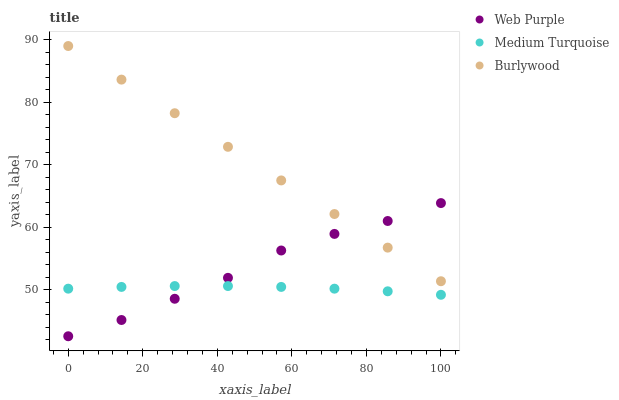Does Medium Turquoise have the minimum area under the curve?
Answer yes or no. Yes. Does Burlywood have the maximum area under the curve?
Answer yes or no. Yes. Does Web Purple have the minimum area under the curve?
Answer yes or no. No. Does Web Purple have the maximum area under the curve?
Answer yes or no. No. Is Burlywood the smoothest?
Answer yes or no. Yes. Is Web Purple the roughest?
Answer yes or no. Yes. Is Medium Turquoise the smoothest?
Answer yes or no. No. Is Medium Turquoise the roughest?
Answer yes or no. No. Does Web Purple have the lowest value?
Answer yes or no. Yes. Does Medium Turquoise have the lowest value?
Answer yes or no. No. Does Burlywood have the highest value?
Answer yes or no. Yes. Does Web Purple have the highest value?
Answer yes or no. No. Is Medium Turquoise less than Burlywood?
Answer yes or no. Yes. Is Burlywood greater than Medium Turquoise?
Answer yes or no. Yes. Does Web Purple intersect Medium Turquoise?
Answer yes or no. Yes. Is Web Purple less than Medium Turquoise?
Answer yes or no. No. Is Web Purple greater than Medium Turquoise?
Answer yes or no. No. Does Medium Turquoise intersect Burlywood?
Answer yes or no. No. 